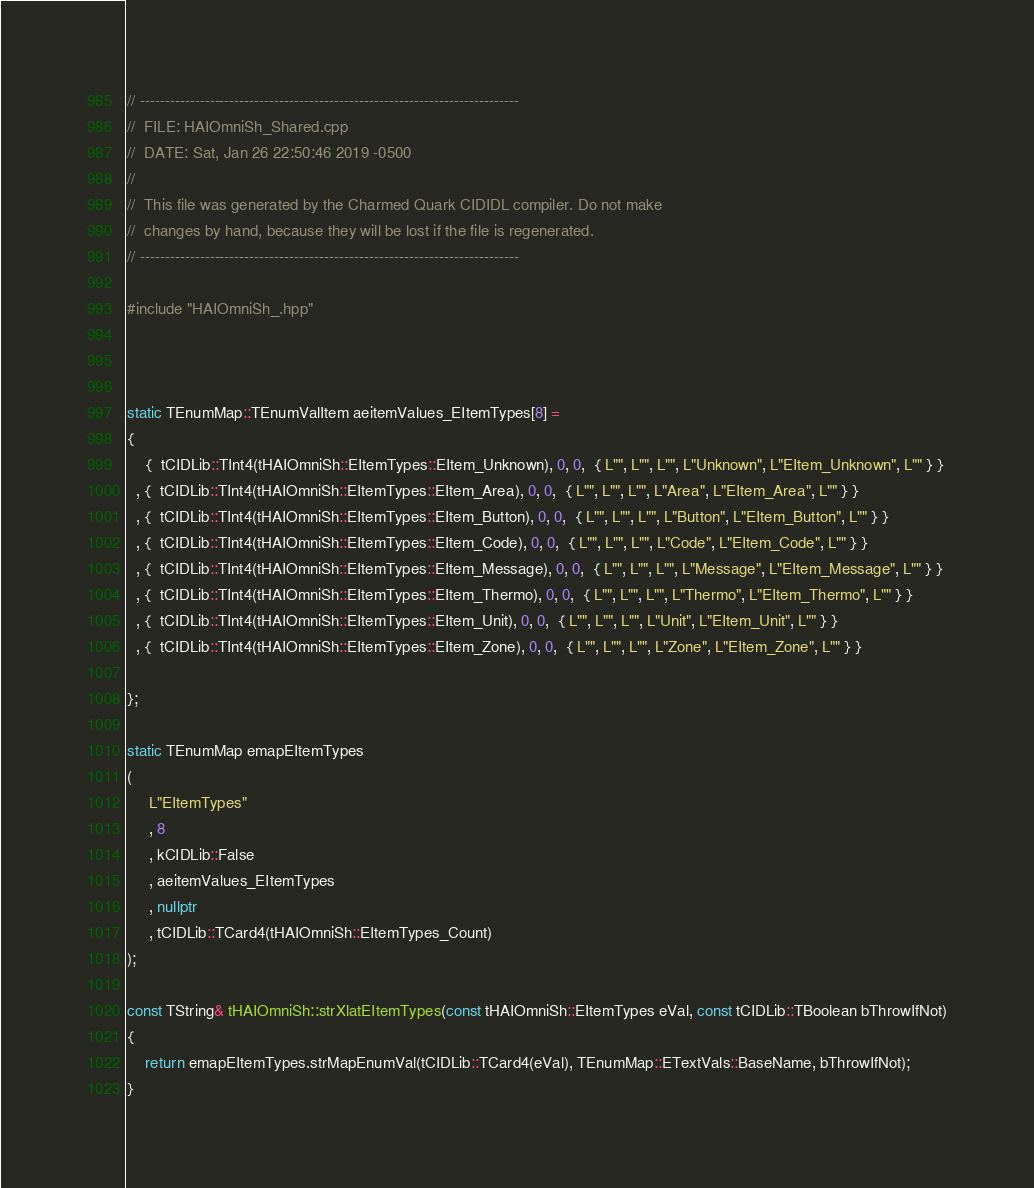Convert code to text. <code><loc_0><loc_0><loc_500><loc_500><_C++_>// ----------------------------------------------------------------------------
//  FILE: HAIOmniSh_Shared.cpp
//  DATE: Sat, Jan 26 22:50:46 2019 -0500
//
//  This file was generated by the Charmed Quark CIDIDL compiler. Do not make
//  changes by hand, because they will be lost if the file is regenerated.
// ----------------------------------------------------------------------------

#include "HAIOmniSh_.hpp"



static TEnumMap::TEnumValItem aeitemValues_EItemTypes[8] = 
{
    {  tCIDLib::TInt4(tHAIOmniSh::EItemTypes::EItem_Unknown), 0, 0,  { L"", L"", L"", L"Unknown", L"EItem_Unknown", L"" } }
  , {  tCIDLib::TInt4(tHAIOmniSh::EItemTypes::EItem_Area), 0, 0,  { L"", L"", L"", L"Area", L"EItem_Area", L"" } }
  , {  tCIDLib::TInt4(tHAIOmniSh::EItemTypes::EItem_Button), 0, 0,  { L"", L"", L"", L"Button", L"EItem_Button", L"" } }
  , {  tCIDLib::TInt4(tHAIOmniSh::EItemTypes::EItem_Code), 0, 0,  { L"", L"", L"", L"Code", L"EItem_Code", L"" } }
  , {  tCIDLib::TInt4(tHAIOmniSh::EItemTypes::EItem_Message), 0, 0,  { L"", L"", L"", L"Message", L"EItem_Message", L"" } }
  , {  tCIDLib::TInt4(tHAIOmniSh::EItemTypes::EItem_Thermo), 0, 0,  { L"", L"", L"", L"Thermo", L"EItem_Thermo", L"" } }
  , {  tCIDLib::TInt4(tHAIOmniSh::EItemTypes::EItem_Unit), 0, 0,  { L"", L"", L"", L"Unit", L"EItem_Unit", L"" } }
  , {  tCIDLib::TInt4(tHAIOmniSh::EItemTypes::EItem_Zone), 0, 0,  { L"", L"", L"", L"Zone", L"EItem_Zone", L"" } }

};

static TEnumMap emapEItemTypes
(
     L"EItemTypes"
     , 8
     , kCIDLib::False
     , aeitemValues_EItemTypes
     , nullptr
     , tCIDLib::TCard4(tHAIOmniSh::EItemTypes_Count)
);

const TString& tHAIOmniSh::strXlatEItemTypes(const tHAIOmniSh::EItemTypes eVal, const tCIDLib::TBoolean bThrowIfNot)
{
    return emapEItemTypes.strMapEnumVal(tCIDLib::TCard4(eVal), TEnumMap::ETextVals::BaseName, bThrowIfNot);
}
</code> 